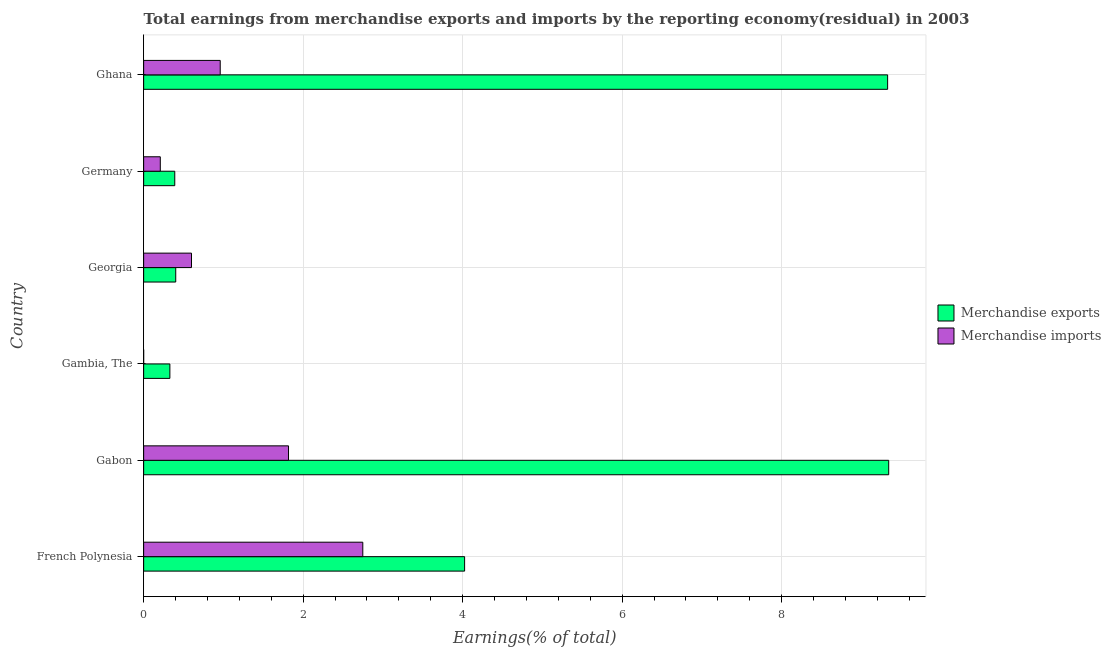Are the number of bars per tick equal to the number of legend labels?
Your answer should be compact. No. Are the number of bars on each tick of the Y-axis equal?
Give a very brief answer. No. How many bars are there on the 5th tick from the top?
Give a very brief answer. 2. How many bars are there on the 4th tick from the bottom?
Provide a succinct answer. 2. What is the label of the 5th group of bars from the top?
Provide a succinct answer. Gabon. What is the earnings from merchandise exports in Germany?
Your response must be concise. 0.39. Across all countries, what is the maximum earnings from merchandise imports?
Your answer should be compact. 2.75. In which country was the earnings from merchandise imports maximum?
Offer a terse response. French Polynesia. What is the total earnings from merchandise imports in the graph?
Offer a very short reply. 6.33. What is the difference between the earnings from merchandise imports in French Polynesia and that in Georgia?
Make the answer very short. 2.15. What is the difference between the earnings from merchandise imports in Georgia and the earnings from merchandise exports in French Polynesia?
Offer a very short reply. -3.42. What is the average earnings from merchandise imports per country?
Provide a succinct answer. 1.06. What is the difference between the earnings from merchandise imports and earnings from merchandise exports in Georgia?
Offer a terse response. 0.2. What is the ratio of the earnings from merchandise imports in Gabon to that in Ghana?
Give a very brief answer. 1.89. What is the difference between the highest and the second highest earnings from merchandise imports?
Offer a very short reply. 0.93. What is the difference between the highest and the lowest earnings from merchandise exports?
Keep it short and to the point. 9.01. In how many countries, is the earnings from merchandise imports greater than the average earnings from merchandise imports taken over all countries?
Your answer should be very brief. 2. Is the sum of the earnings from merchandise imports in Germany and Ghana greater than the maximum earnings from merchandise exports across all countries?
Offer a very short reply. No. How many bars are there?
Make the answer very short. 11. How many countries are there in the graph?
Your answer should be very brief. 6. What is the difference between two consecutive major ticks on the X-axis?
Your response must be concise. 2. Are the values on the major ticks of X-axis written in scientific E-notation?
Your answer should be very brief. No. Does the graph contain any zero values?
Provide a short and direct response. Yes. Does the graph contain grids?
Ensure brevity in your answer.  Yes. How are the legend labels stacked?
Provide a succinct answer. Vertical. What is the title of the graph?
Your answer should be compact. Total earnings from merchandise exports and imports by the reporting economy(residual) in 2003. What is the label or title of the X-axis?
Make the answer very short. Earnings(% of total). What is the label or title of the Y-axis?
Provide a short and direct response. Country. What is the Earnings(% of total) in Merchandise exports in French Polynesia?
Give a very brief answer. 4.02. What is the Earnings(% of total) of Merchandise imports in French Polynesia?
Keep it short and to the point. 2.75. What is the Earnings(% of total) in Merchandise exports in Gabon?
Your response must be concise. 9.34. What is the Earnings(% of total) of Merchandise imports in Gabon?
Ensure brevity in your answer.  1.82. What is the Earnings(% of total) of Merchandise exports in Gambia, The?
Provide a succinct answer. 0.33. What is the Earnings(% of total) of Merchandise exports in Georgia?
Provide a short and direct response. 0.4. What is the Earnings(% of total) in Merchandise imports in Georgia?
Give a very brief answer. 0.6. What is the Earnings(% of total) of Merchandise exports in Germany?
Give a very brief answer. 0.39. What is the Earnings(% of total) of Merchandise imports in Germany?
Offer a very short reply. 0.21. What is the Earnings(% of total) of Merchandise exports in Ghana?
Offer a very short reply. 9.33. What is the Earnings(% of total) of Merchandise imports in Ghana?
Make the answer very short. 0.96. Across all countries, what is the maximum Earnings(% of total) of Merchandise exports?
Keep it short and to the point. 9.34. Across all countries, what is the maximum Earnings(% of total) of Merchandise imports?
Ensure brevity in your answer.  2.75. Across all countries, what is the minimum Earnings(% of total) of Merchandise exports?
Your answer should be very brief. 0.33. What is the total Earnings(% of total) in Merchandise exports in the graph?
Your response must be concise. 23.82. What is the total Earnings(% of total) of Merchandise imports in the graph?
Provide a succinct answer. 6.33. What is the difference between the Earnings(% of total) in Merchandise exports in French Polynesia and that in Gabon?
Your answer should be compact. -5.32. What is the difference between the Earnings(% of total) in Merchandise imports in French Polynesia and that in Gabon?
Provide a short and direct response. 0.93. What is the difference between the Earnings(% of total) of Merchandise exports in French Polynesia and that in Gambia, The?
Ensure brevity in your answer.  3.7. What is the difference between the Earnings(% of total) of Merchandise exports in French Polynesia and that in Georgia?
Provide a succinct answer. 3.62. What is the difference between the Earnings(% of total) of Merchandise imports in French Polynesia and that in Georgia?
Your answer should be compact. 2.15. What is the difference between the Earnings(% of total) in Merchandise exports in French Polynesia and that in Germany?
Provide a succinct answer. 3.63. What is the difference between the Earnings(% of total) of Merchandise imports in French Polynesia and that in Germany?
Keep it short and to the point. 2.54. What is the difference between the Earnings(% of total) in Merchandise exports in French Polynesia and that in Ghana?
Provide a succinct answer. -5.3. What is the difference between the Earnings(% of total) of Merchandise imports in French Polynesia and that in Ghana?
Offer a terse response. 1.79. What is the difference between the Earnings(% of total) of Merchandise exports in Gabon and that in Gambia, The?
Ensure brevity in your answer.  9.01. What is the difference between the Earnings(% of total) of Merchandise exports in Gabon and that in Georgia?
Your answer should be very brief. 8.94. What is the difference between the Earnings(% of total) of Merchandise imports in Gabon and that in Georgia?
Offer a very short reply. 1.22. What is the difference between the Earnings(% of total) in Merchandise exports in Gabon and that in Germany?
Offer a very short reply. 8.95. What is the difference between the Earnings(% of total) of Merchandise imports in Gabon and that in Germany?
Your answer should be very brief. 1.61. What is the difference between the Earnings(% of total) in Merchandise exports in Gabon and that in Ghana?
Make the answer very short. 0.01. What is the difference between the Earnings(% of total) of Merchandise imports in Gabon and that in Ghana?
Make the answer very short. 0.86. What is the difference between the Earnings(% of total) in Merchandise exports in Gambia, The and that in Georgia?
Make the answer very short. -0.07. What is the difference between the Earnings(% of total) in Merchandise exports in Gambia, The and that in Germany?
Offer a very short reply. -0.06. What is the difference between the Earnings(% of total) in Merchandise exports in Georgia and that in Germany?
Provide a short and direct response. 0.01. What is the difference between the Earnings(% of total) of Merchandise imports in Georgia and that in Germany?
Your response must be concise. 0.39. What is the difference between the Earnings(% of total) of Merchandise exports in Georgia and that in Ghana?
Provide a succinct answer. -8.93. What is the difference between the Earnings(% of total) in Merchandise imports in Georgia and that in Ghana?
Provide a succinct answer. -0.36. What is the difference between the Earnings(% of total) of Merchandise exports in Germany and that in Ghana?
Provide a short and direct response. -8.94. What is the difference between the Earnings(% of total) of Merchandise imports in Germany and that in Ghana?
Provide a short and direct response. -0.75. What is the difference between the Earnings(% of total) of Merchandise exports in French Polynesia and the Earnings(% of total) of Merchandise imports in Gabon?
Make the answer very short. 2.21. What is the difference between the Earnings(% of total) of Merchandise exports in French Polynesia and the Earnings(% of total) of Merchandise imports in Georgia?
Your answer should be compact. 3.42. What is the difference between the Earnings(% of total) in Merchandise exports in French Polynesia and the Earnings(% of total) in Merchandise imports in Germany?
Ensure brevity in your answer.  3.82. What is the difference between the Earnings(% of total) of Merchandise exports in French Polynesia and the Earnings(% of total) of Merchandise imports in Ghana?
Your response must be concise. 3.06. What is the difference between the Earnings(% of total) of Merchandise exports in Gabon and the Earnings(% of total) of Merchandise imports in Georgia?
Offer a very short reply. 8.74. What is the difference between the Earnings(% of total) of Merchandise exports in Gabon and the Earnings(% of total) of Merchandise imports in Germany?
Make the answer very short. 9.13. What is the difference between the Earnings(% of total) in Merchandise exports in Gabon and the Earnings(% of total) in Merchandise imports in Ghana?
Keep it short and to the point. 8.38. What is the difference between the Earnings(% of total) of Merchandise exports in Gambia, The and the Earnings(% of total) of Merchandise imports in Georgia?
Keep it short and to the point. -0.27. What is the difference between the Earnings(% of total) in Merchandise exports in Gambia, The and the Earnings(% of total) in Merchandise imports in Germany?
Your response must be concise. 0.12. What is the difference between the Earnings(% of total) of Merchandise exports in Gambia, The and the Earnings(% of total) of Merchandise imports in Ghana?
Ensure brevity in your answer.  -0.63. What is the difference between the Earnings(% of total) of Merchandise exports in Georgia and the Earnings(% of total) of Merchandise imports in Germany?
Provide a succinct answer. 0.19. What is the difference between the Earnings(% of total) in Merchandise exports in Georgia and the Earnings(% of total) in Merchandise imports in Ghana?
Keep it short and to the point. -0.56. What is the difference between the Earnings(% of total) in Merchandise exports in Germany and the Earnings(% of total) in Merchandise imports in Ghana?
Keep it short and to the point. -0.57. What is the average Earnings(% of total) in Merchandise exports per country?
Keep it short and to the point. 3.97. What is the average Earnings(% of total) in Merchandise imports per country?
Your answer should be compact. 1.06. What is the difference between the Earnings(% of total) in Merchandise exports and Earnings(% of total) in Merchandise imports in French Polynesia?
Give a very brief answer. 1.28. What is the difference between the Earnings(% of total) in Merchandise exports and Earnings(% of total) in Merchandise imports in Gabon?
Your response must be concise. 7.53. What is the difference between the Earnings(% of total) of Merchandise exports and Earnings(% of total) of Merchandise imports in Georgia?
Provide a short and direct response. -0.2. What is the difference between the Earnings(% of total) in Merchandise exports and Earnings(% of total) in Merchandise imports in Germany?
Offer a very short reply. 0.18. What is the difference between the Earnings(% of total) of Merchandise exports and Earnings(% of total) of Merchandise imports in Ghana?
Your response must be concise. 8.37. What is the ratio of the Earnings(% of total) in Merchandise exports in French Polynesia to that in Gabon?
Provide a short and direct response. 0.43. What is the ratio of the Earnings(% of total) of Merchandise imports in French Polynesia to that in Gabon?
Offer a terse response. 1.51. What is the ratio of the Earnings(% of total) of Merchandise exports in French Polynesia to that in Gambia, The?
Your answer should be very brief. 12.24. What is the ratio of the Earnings(% of total) in Merchandise exports in French Polynesia to that in Georgia?
Your answer should be compact. 10. What is the ratio of the Earnings(% of total) of Merchandise imports in French Polynesia to that in Georgia?
Provide a succinct answer. 4.58. What is the ratio of the Earnings(% of total) in Merchandise exports in French Polynesia to that in Germany?
Your response must be concise. 10.31. What is the ratio of the Earnings(% of total) of Merchandise imports in French Polynesia to that in Germany?
Provide a succinct answer. 13.17. What is the ratio of the Earnings(% of total) of Merchandise exports in French Polynesia to that in Ghana?
Offer a terse response. 0.43. What is the ratio of the Earnings(% of total) in Merchandise imports in French Polynesia to that in Ghana?
Keep it short and to the point. 2.86. What is the ratio of the Earnings(% of total) in Merchandise exports in Gabon to that in Gambia, The?
Offer a terse response. 28.41. What is the ratio of the Earnings(% of total) in Merchandise exports in Gabon to that in Georgia?
Your answer should be compact. 23.22. What is the ratio of the Earnings(% of total) in Merchandise imports in Gabon to that in Georgia?
Your response must be concise. 3.03. What is the ratio of the Earnings(% of total) of Merchandise exports in Gabon to that in Germany?
Keep it short and to the point. 23.94. What is the ratio of the Earnings(% of total) of Merchandise imports in Gabon to that in Germany?
Your answer should be very brief. 8.7. What is the ratio of the Earnings(% of total) in Merchandise imports in Gabon to that in Ghana?
Provide a succinct answer. 1.89. What is the ratio of the Earnings(% of total) of Merchandise exports in Gambia, The to that in Georgia?
Offer a terse response. 0.82. What is the ratio of the Earnings(% of total) in Merchandise exports in Gambia, The to that in Germany?
Give a very brief answer. 0.84. What is the ratio of the Earnings(% of total) of Merchandise exports in Gambia, The to that in Ghana?
Your answer should be compact. 0.04. What is the ratio of the Earnings(% of total) of Merchandise exports in Georgia to that in Germany?
Ensure brevity in your answer.  1.03. What is the ratio of the Earnings(% of total) of Merchandise imports in Georgia to that in Germany?
Offer a very short reply. 2.87. What is the ratio of the Earnings(% of total) in Merchandise exports in Georgia to that in Ghana?
Your answer should be compact. 0.04. What is the ratio of the Earnings(% of total) of Merchandise imports in Georgia to that in Ghana?
Make the answer very short. 0.62. What is the ratio of the Earnings(% of total) in Merchandise exports in Germany to that in Ghana?
Your answer should be very brief. 0.04. What is the ratio of the Earnings(% of total) of Merchandise imports in Germany to that in Ghana?
Offer a terse response. 0.22. What is the difference between the highest and the second highest Earnings(% of total) in Merchandise exports?
Provide a succinct answer. 0.01. What is the difference between the highest and the second highest Earnings(% of total) of Merchandise imports?
Give a very brief answer. 0.93. What is the difference between the highest and the lowest Earnings(% of total) of Merchandise exports?
Provide a succinct answer. 9.01. What is the difference between the highest and the lowest Earnings(% of total) in Merchandise imports?
Make the answer very short. 2.75. 